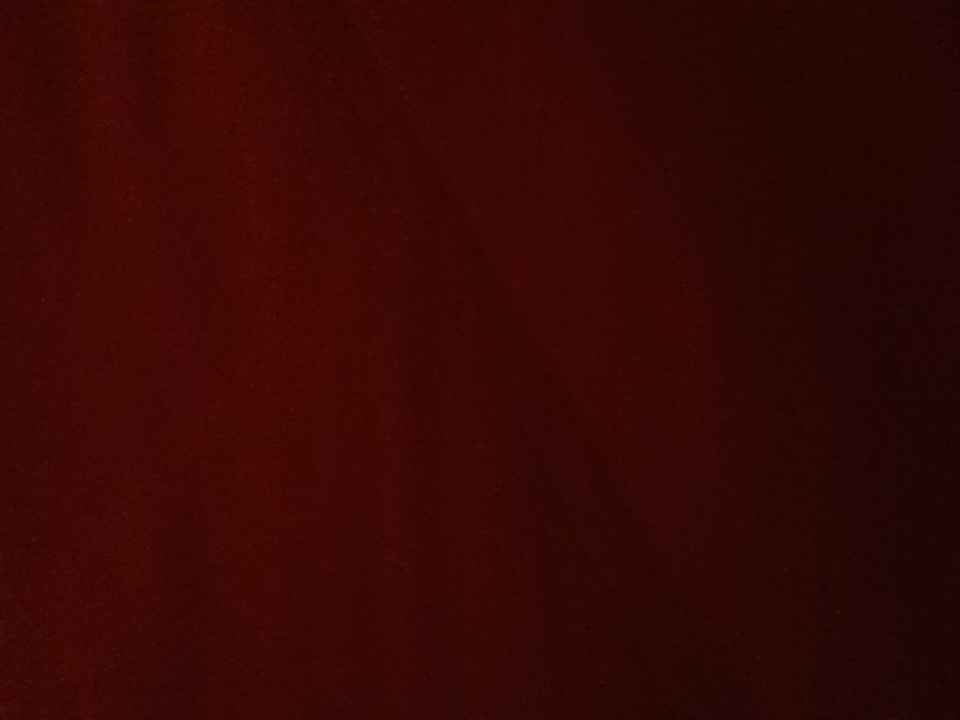What color is this please? The color in the image is a deep, rich shade of red. It appears to be a dark red hue, possibly similar to burgundy or maroon. 